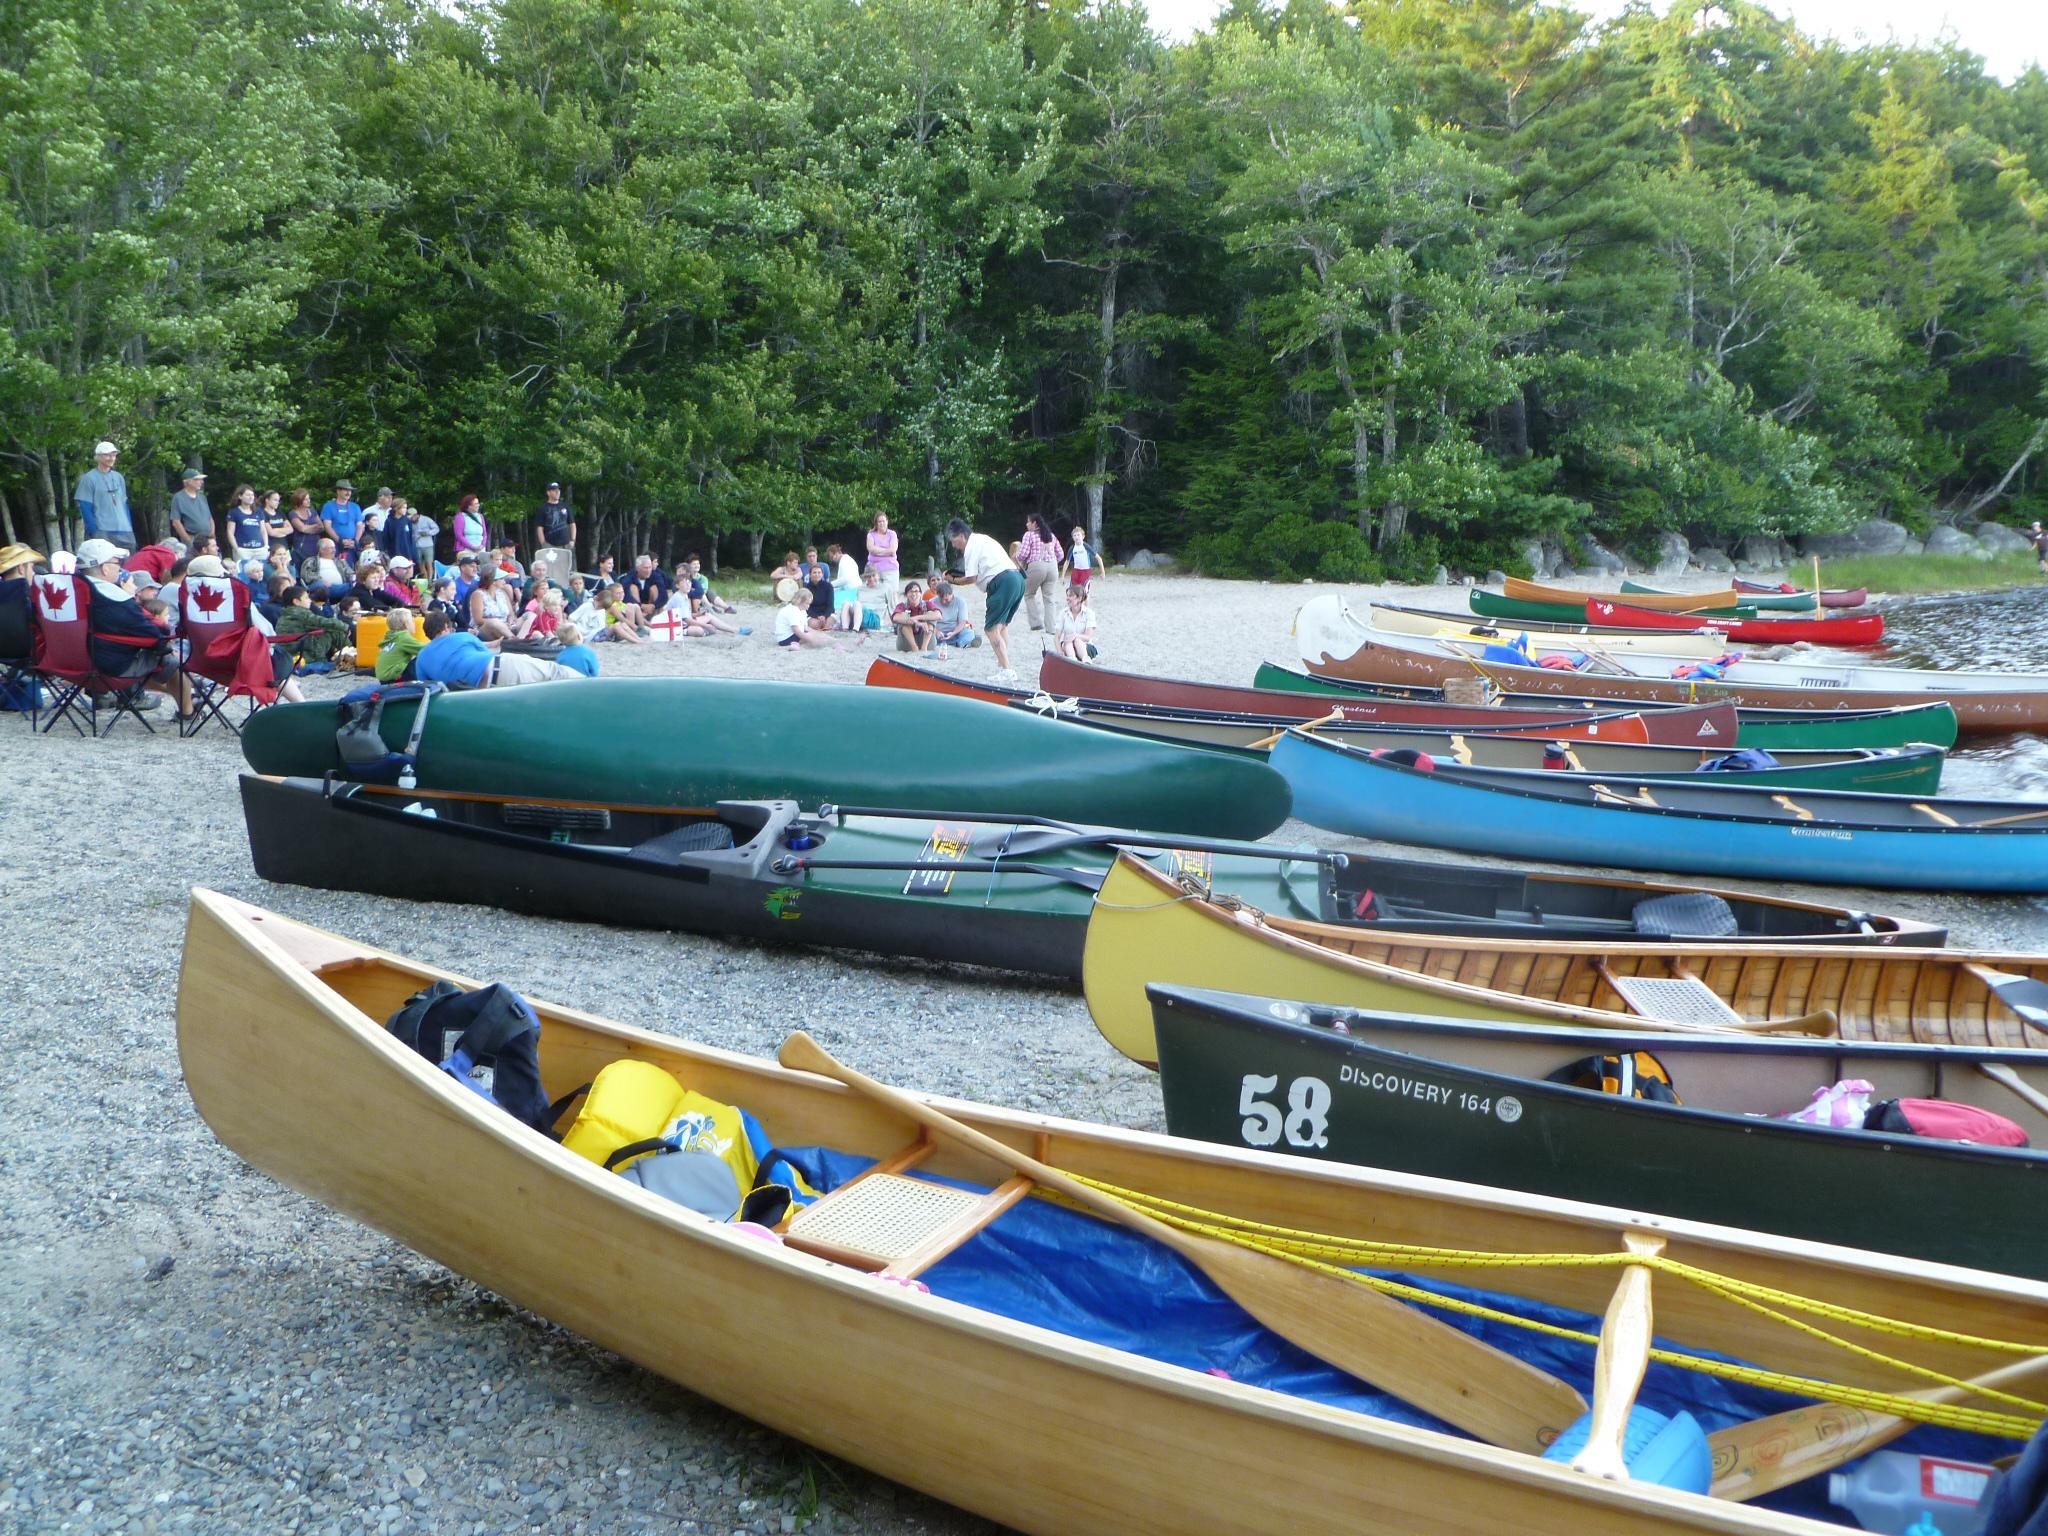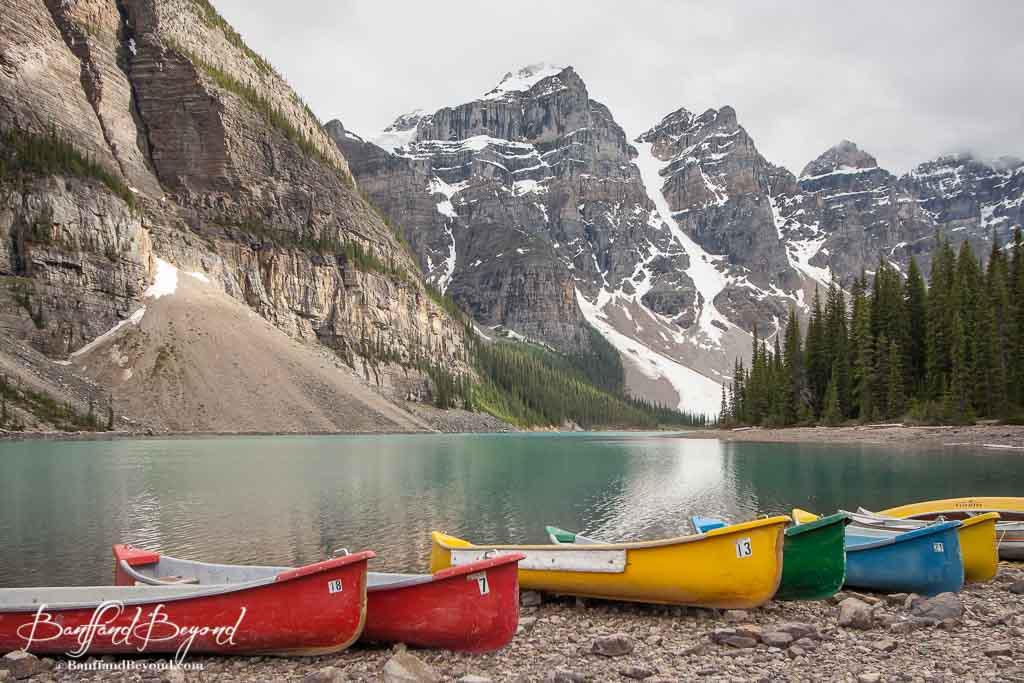The first image is the image on the left, the second image is the image on the right. Assess this claim about the two images: "There are at least six boats in the image on the right.". Correct or not? Answer yes or no. Yes. 